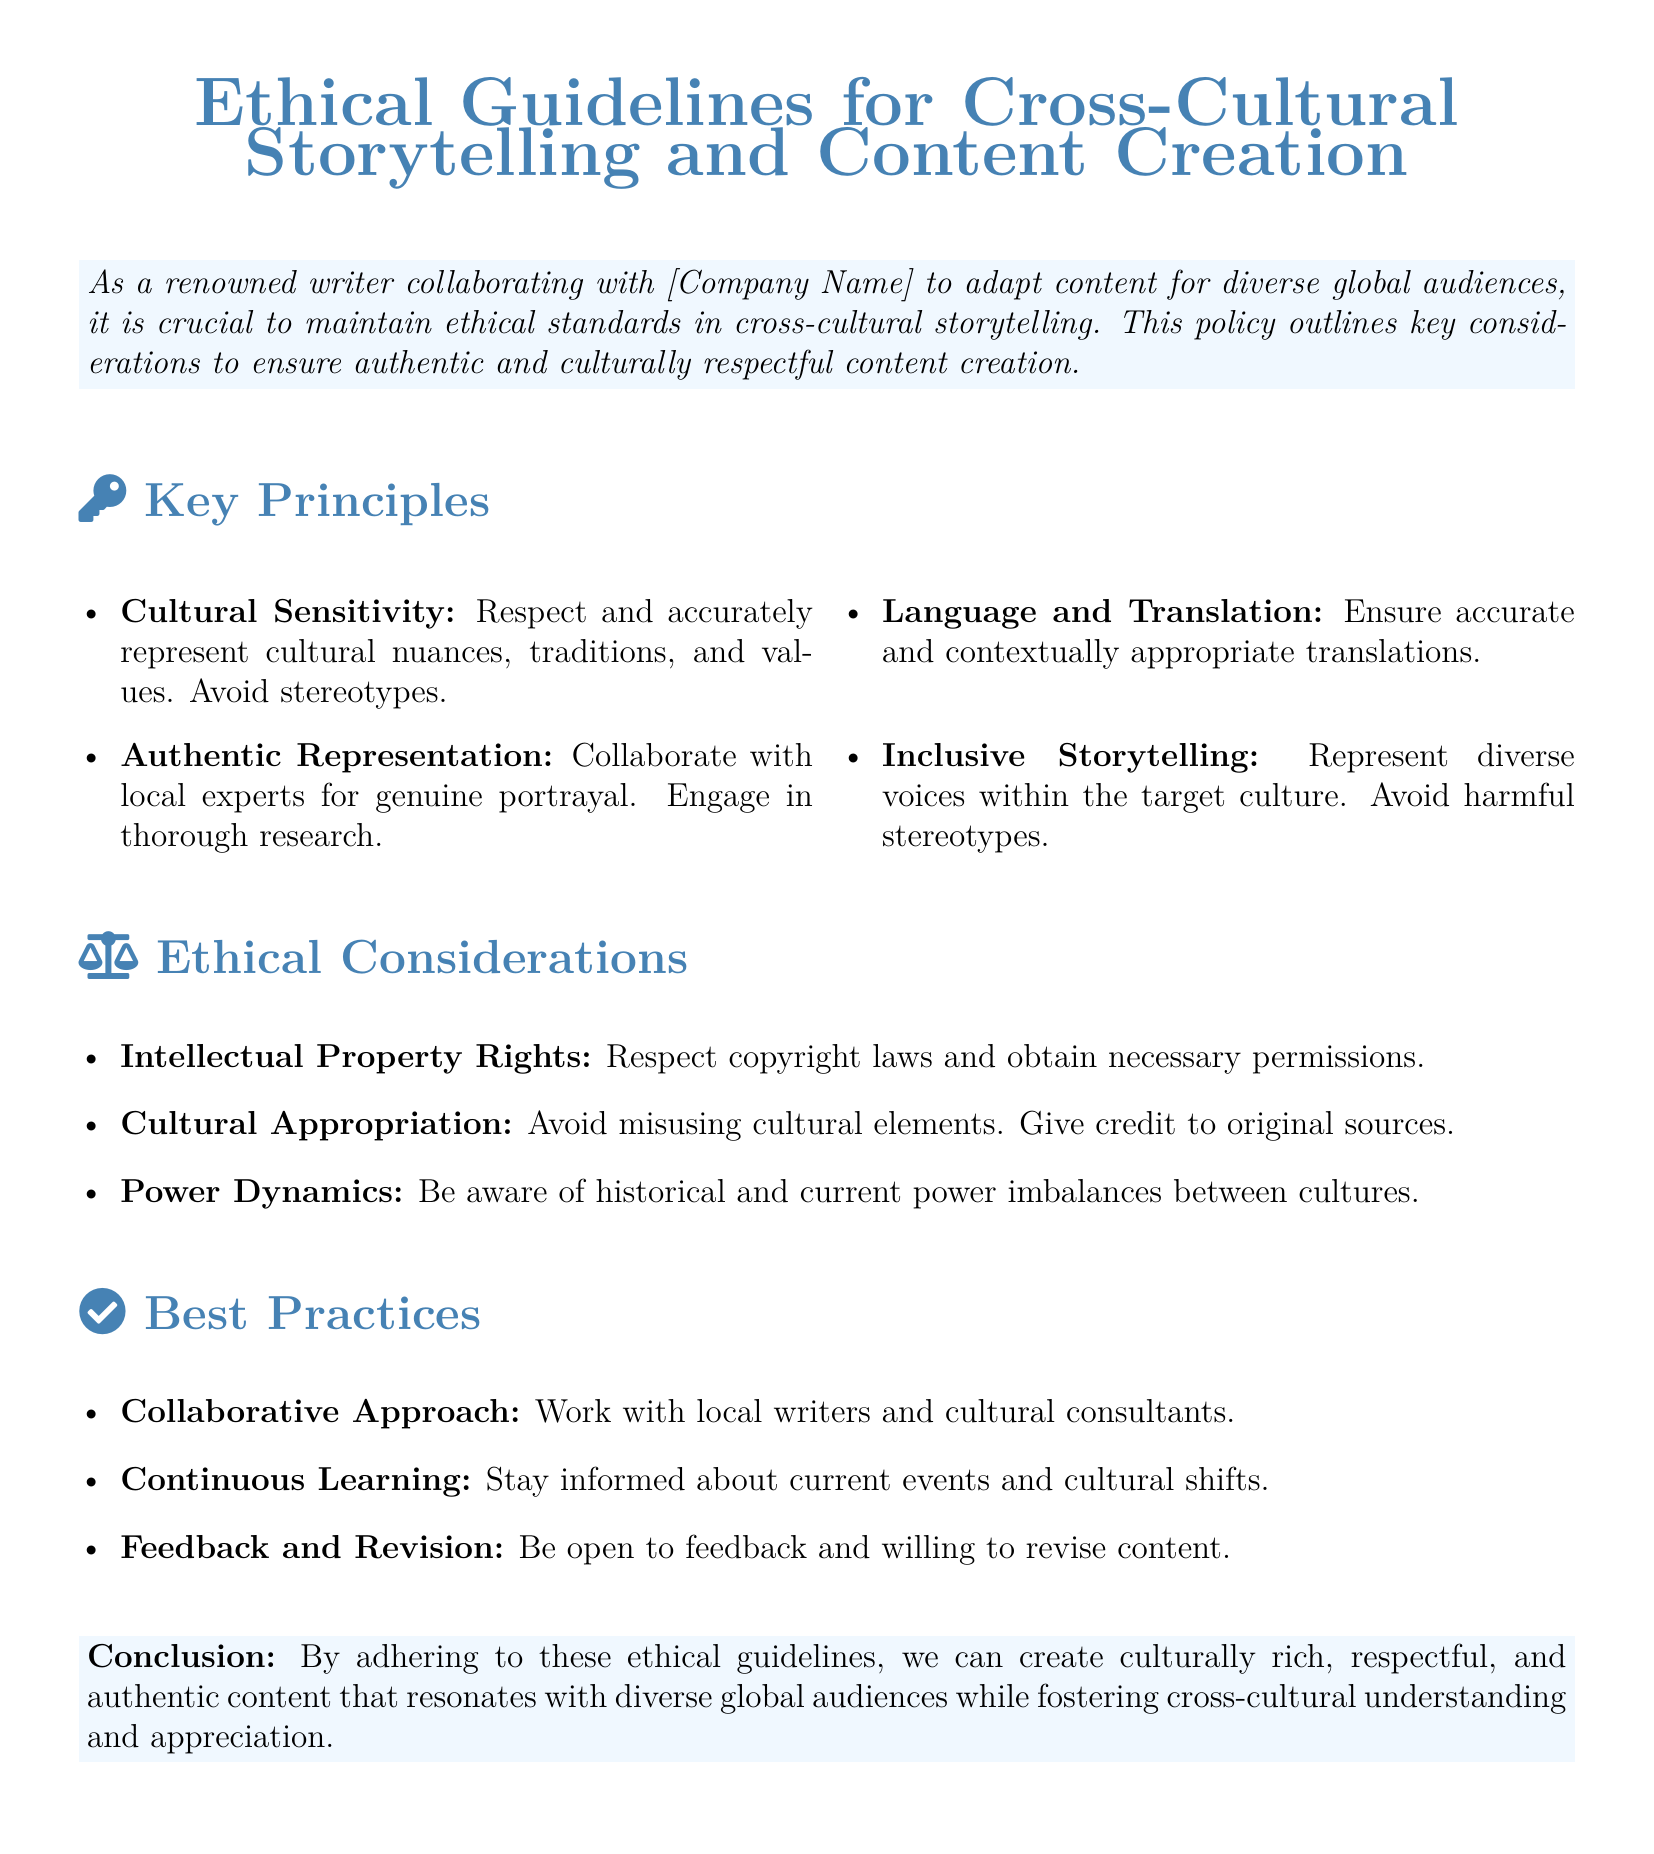What is the title of the document? The title appears at the beginning of the document, stating the focus on ethical guidelines.
Answer: Ethical Guidelines for Cross-Cultural Storytelling and Content Creation What is a key principle mentioned in the document? The document lists several key principles that are crucial for ethical storytelling.
Answer: Cultural Sensitivity How many key principles are listed in the document? The document outlines four key principles under the Key Principles section.
Answer: Four What ethical consideration addresses power imbalances? The document discusses power dynamics as a factor in ethical considerations.
Answer: Power Dynamics What is a best practice suggested in the document? The document provides specific recommended actions to follow for ethical content creation.
Answer: Collaborative Approach What color is used for the main title text? The color scheme for the title is specified within the document.
Answer: Maincolor Who is encouraged to collaborate with writers according to the ethical guidelines? The document emphasizes working with local experts for proper representation.
Answer: Local experts What should be avoided to respect cultural integrity, as mentioned in the document? The document advises against certain actions to maintain respect for cultures.
Answer: Cultural Appropriation 